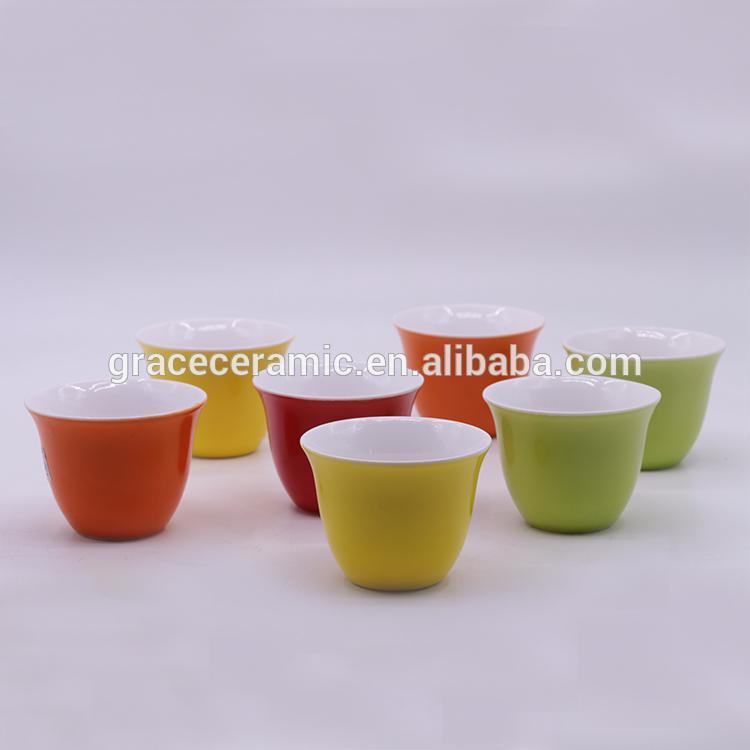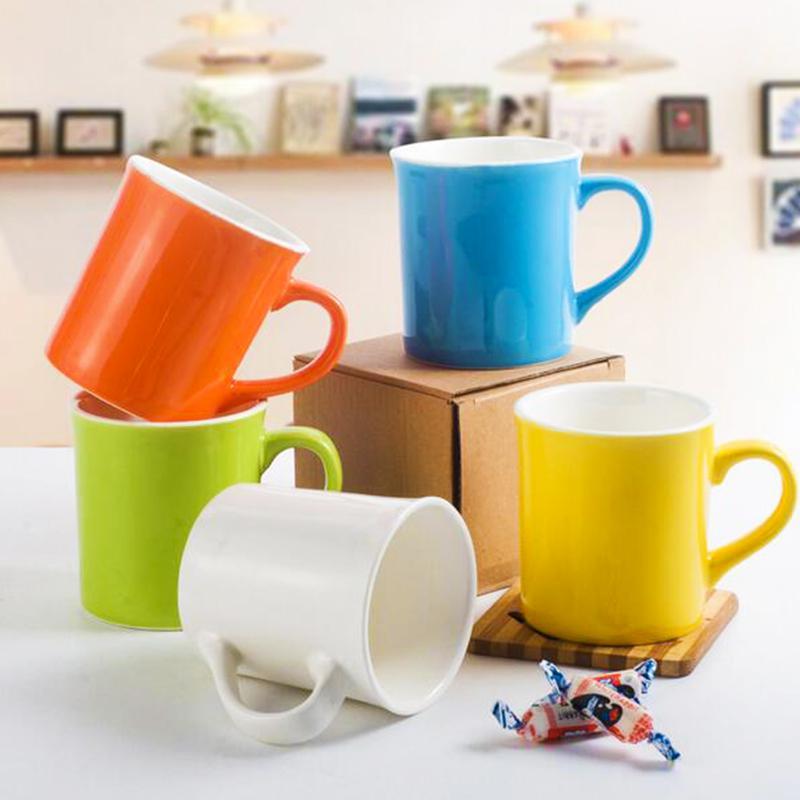The first image is the image on the left, the second image is the image on the right. Considering the images on both sides, is "At least 4 cups are each placed on top of matching colored plates." valid? Answer yes or no. No. The first image is the image on the left, the second image is the image on the right. Evaluate the accuracy of this statement regarding the images: "In one image, the teacups are all the same color as the saucers they're sitting on.". Is it true? Answer yes or no. No. 